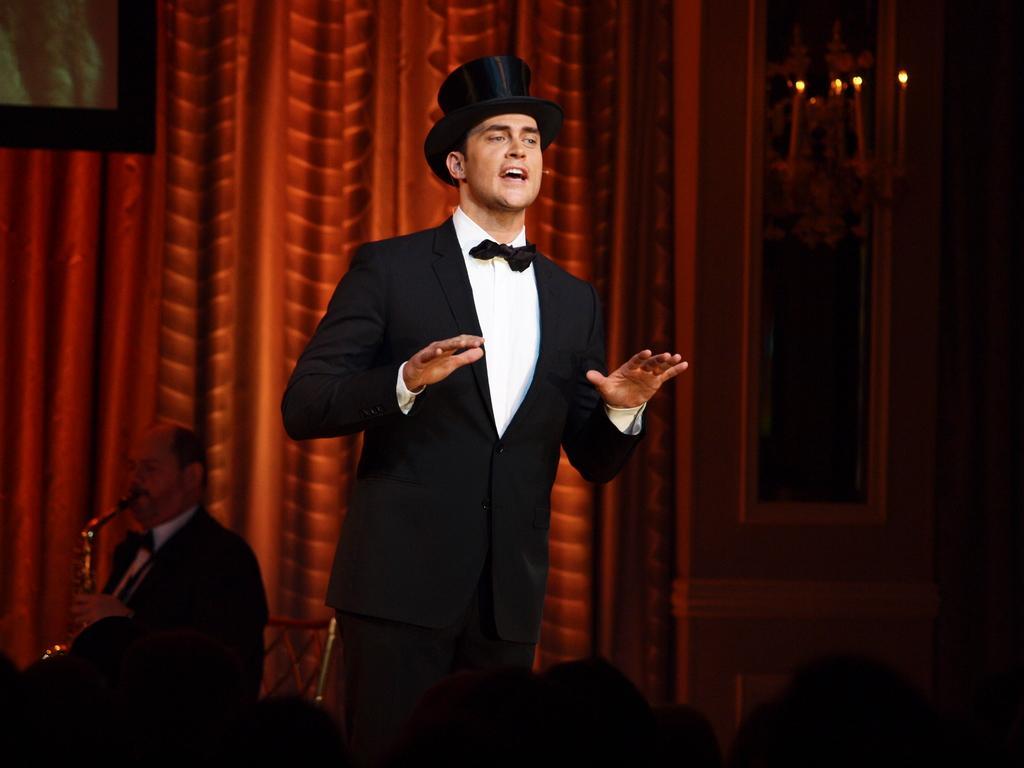Describe this image in one or two sentences. In this image I can see one person is standing and wearing white and black color. Back I can see person is sitting and holding musical instrument. Background is in brown color and I can see few candles and the wall. 